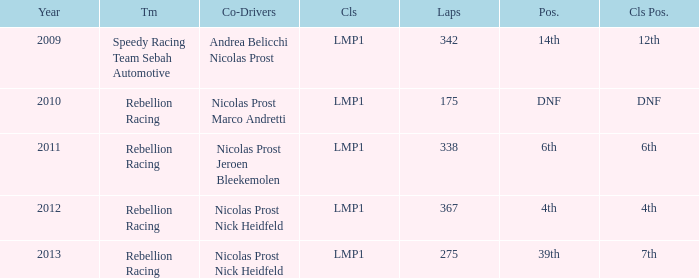What is Class Pos., when Year is before 2013, and when Laps is greater than 175? 12th, 6th, 4th. 